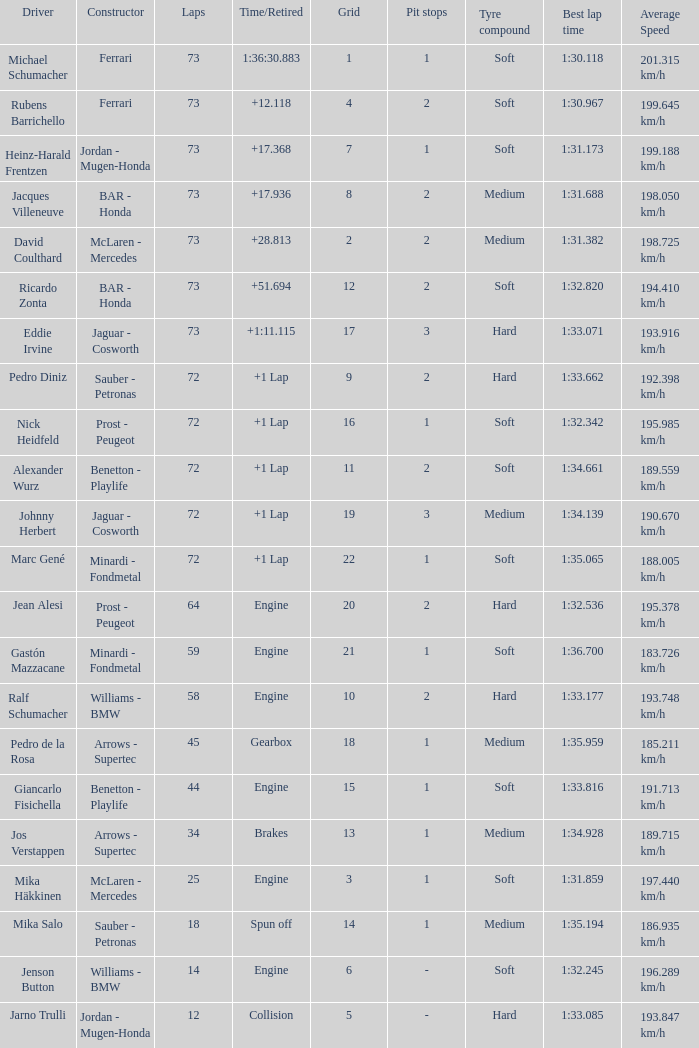How many laps did Giancarlo Fisichella do with a grid larger than 15? 0.0. 